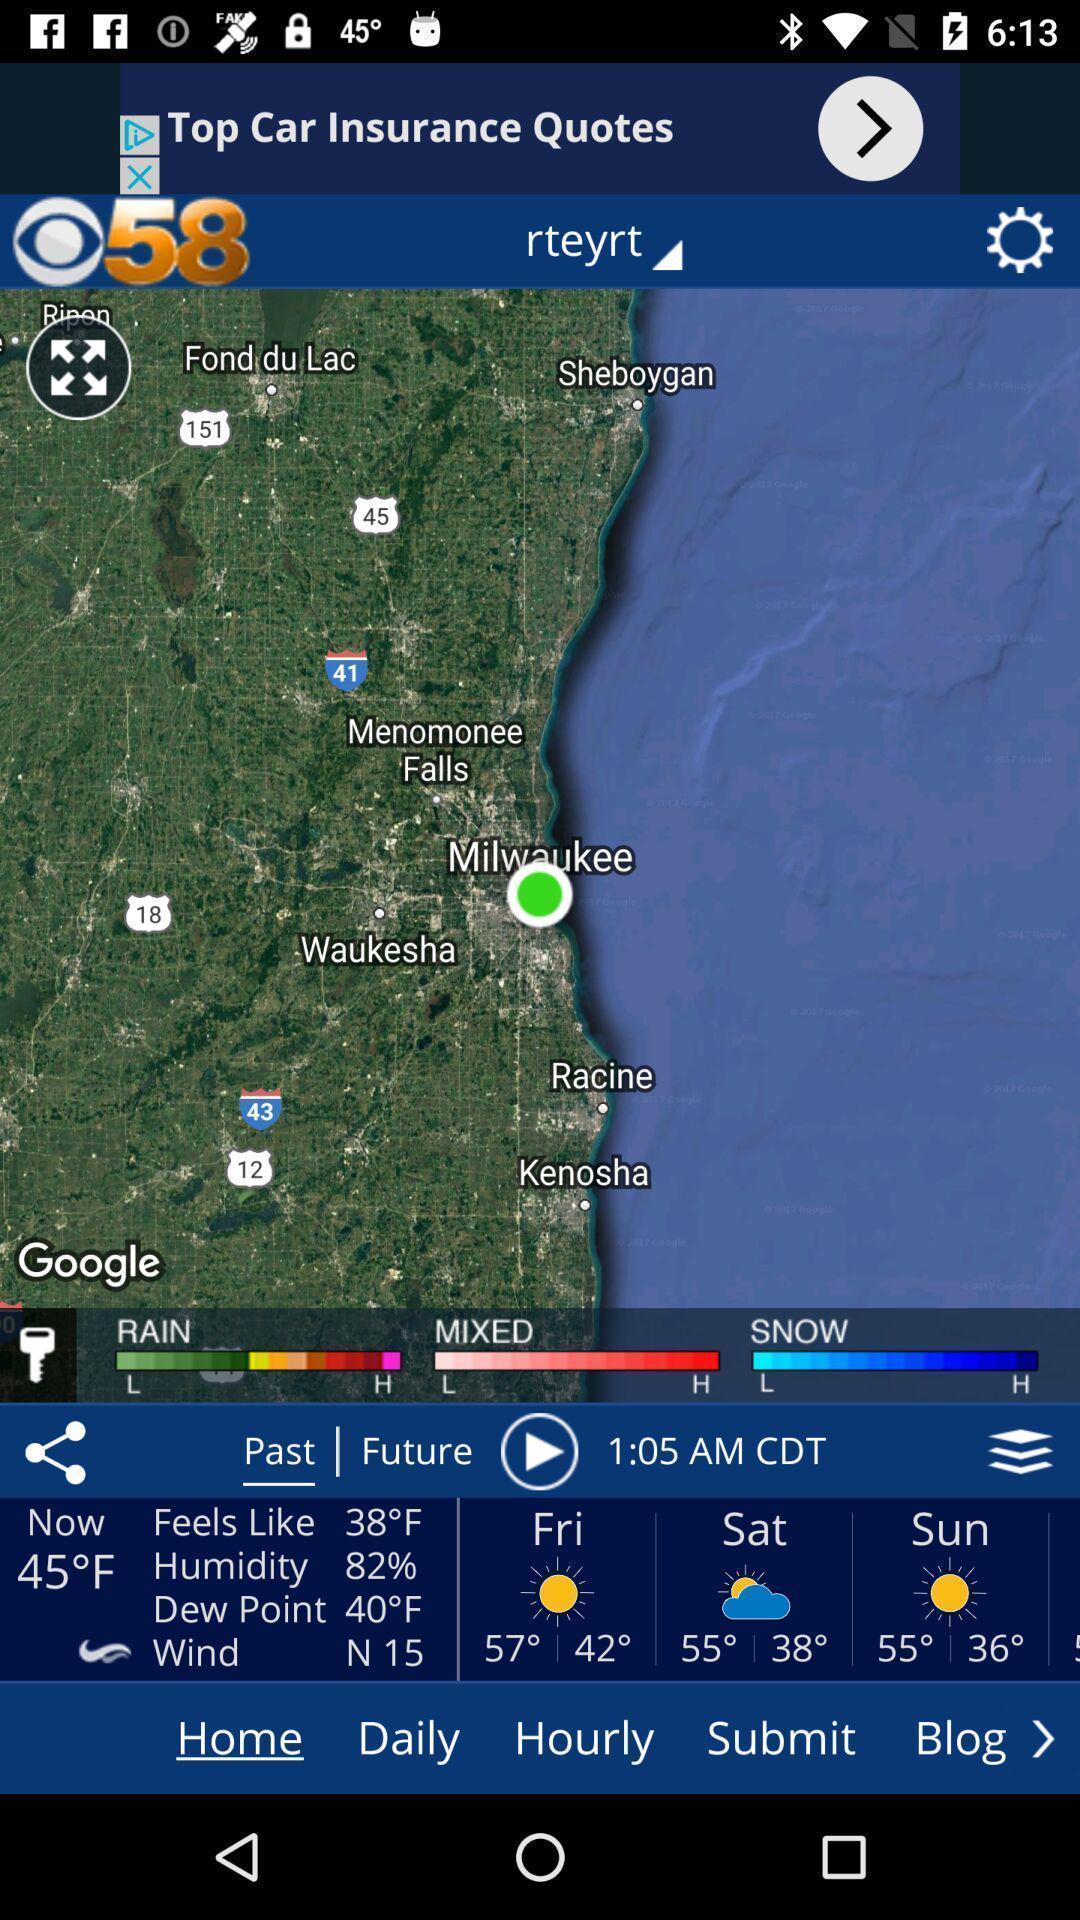Provide a textual representation of this image. Screen showing home page of a weather app. 